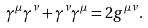<formula> <loc_0><loc_0><loc_500><loc_500>\gamma ^ { \mu } \gamma ^ { \nu } + \gamma ^ { \nu } \gamma ^ { \mu } = 2 g ^ { \mu \nu } .</formula> 